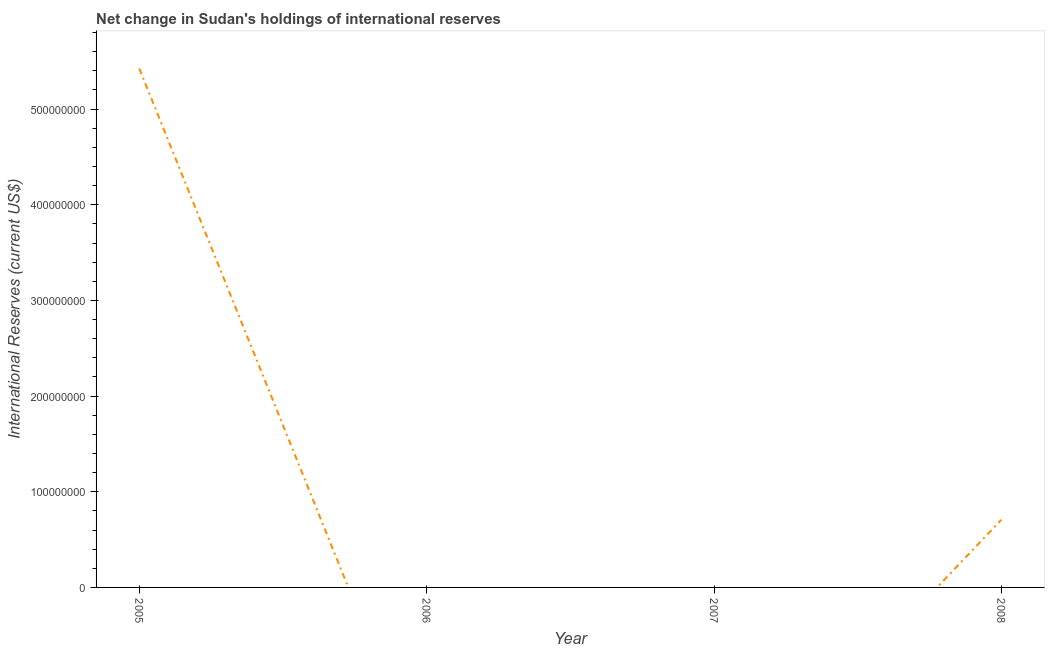Across all years, what is the maximum reserves and related items?
Your answer should be compact. 5.42e+08. Across all years, what is the minimum reserves and related items?
Provide a short and direct response. 0. In which year was the reserves and related items maximum?
Ensure brevity in your answer.  2005. What is the sum of the reserves and related items?
Ensure brevity in your answer.  6.13e+08. What is the difference between the reserves and related items in 2005 and 2008?
Your answer should be compact. 4.72e+08. What is the average reserves and related items per year?
Give a very brief answer. 1.53e+08. What is the median reserves and related items?
Offer a terse response. 3.54e+07. What is the difference between the highest and the lowest reserves and related items?
Make the answer very short. 5.42e+08. In how many years, is the reserves and related items greater than the average reserves and related items taken over all years?
Make the answer very short. 1. Are the values on the major ticks of Y-axis written in scientific E-notation?
Your answer should be compact. No. What is the title of the graph?
Give a very brief answer. Net change in Sudan's holdings of international reserves. What is the label or title of the Y-axis?
Keep it short and to the point. International Reserves (current US$). What is the International Reserves (current US$) of 2005?
Keep it short and to the point. 5.42e+08. What is the International Reserves (current US$) of 2008?
Offer a very short reply. 7.08e+07. What is the difference between the International Reserves (current US$) in 2005 and 2008?
Provide a short and direct response. 4.72e+08. What is the ratio of the International Reserves (current US$) in 2005 to that in 2008?
Your answer should be compact. 7.66. 